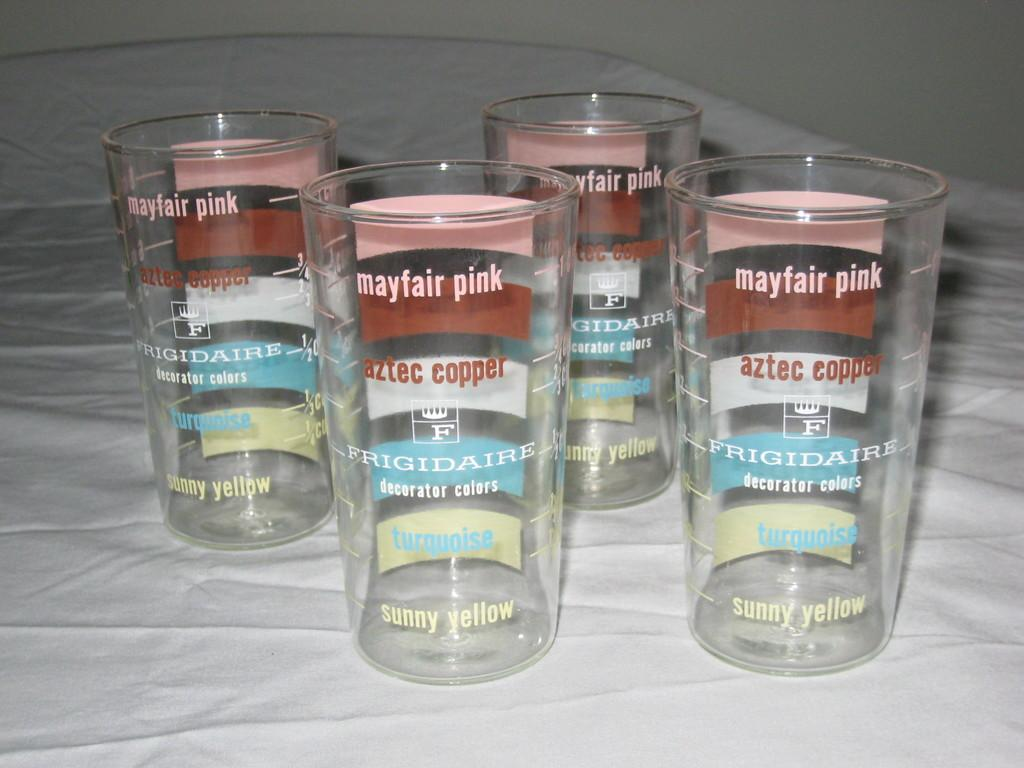Provide a one-sentence caption for the provided image. Frigidaire has put decorator colors on the glasses. 